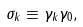Convert formula to latex. <formula><loc_0><loc_0><loc_500><loc_500>\sigma _ { k } \equiv \gamma _ { k } \gamma _ { 0 } ,</formula> 